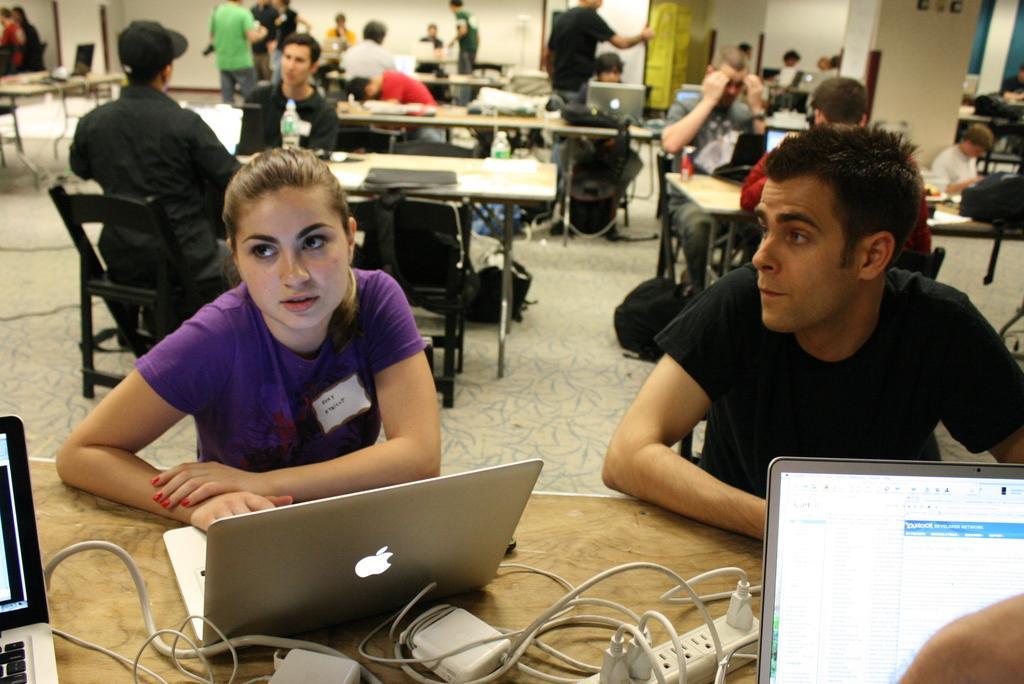Describe this image in one or two sentences. In this image few persons are sitting on the chairs. Before them there are tables. Left side there is a woman sitting behind the table. On the table there are few laptops and plug boards are on it. Beside the woman there is a person wearing a black T-shirt is sitting on the chair. Few persons are standing on the floor. Background there are doors to the wall. 